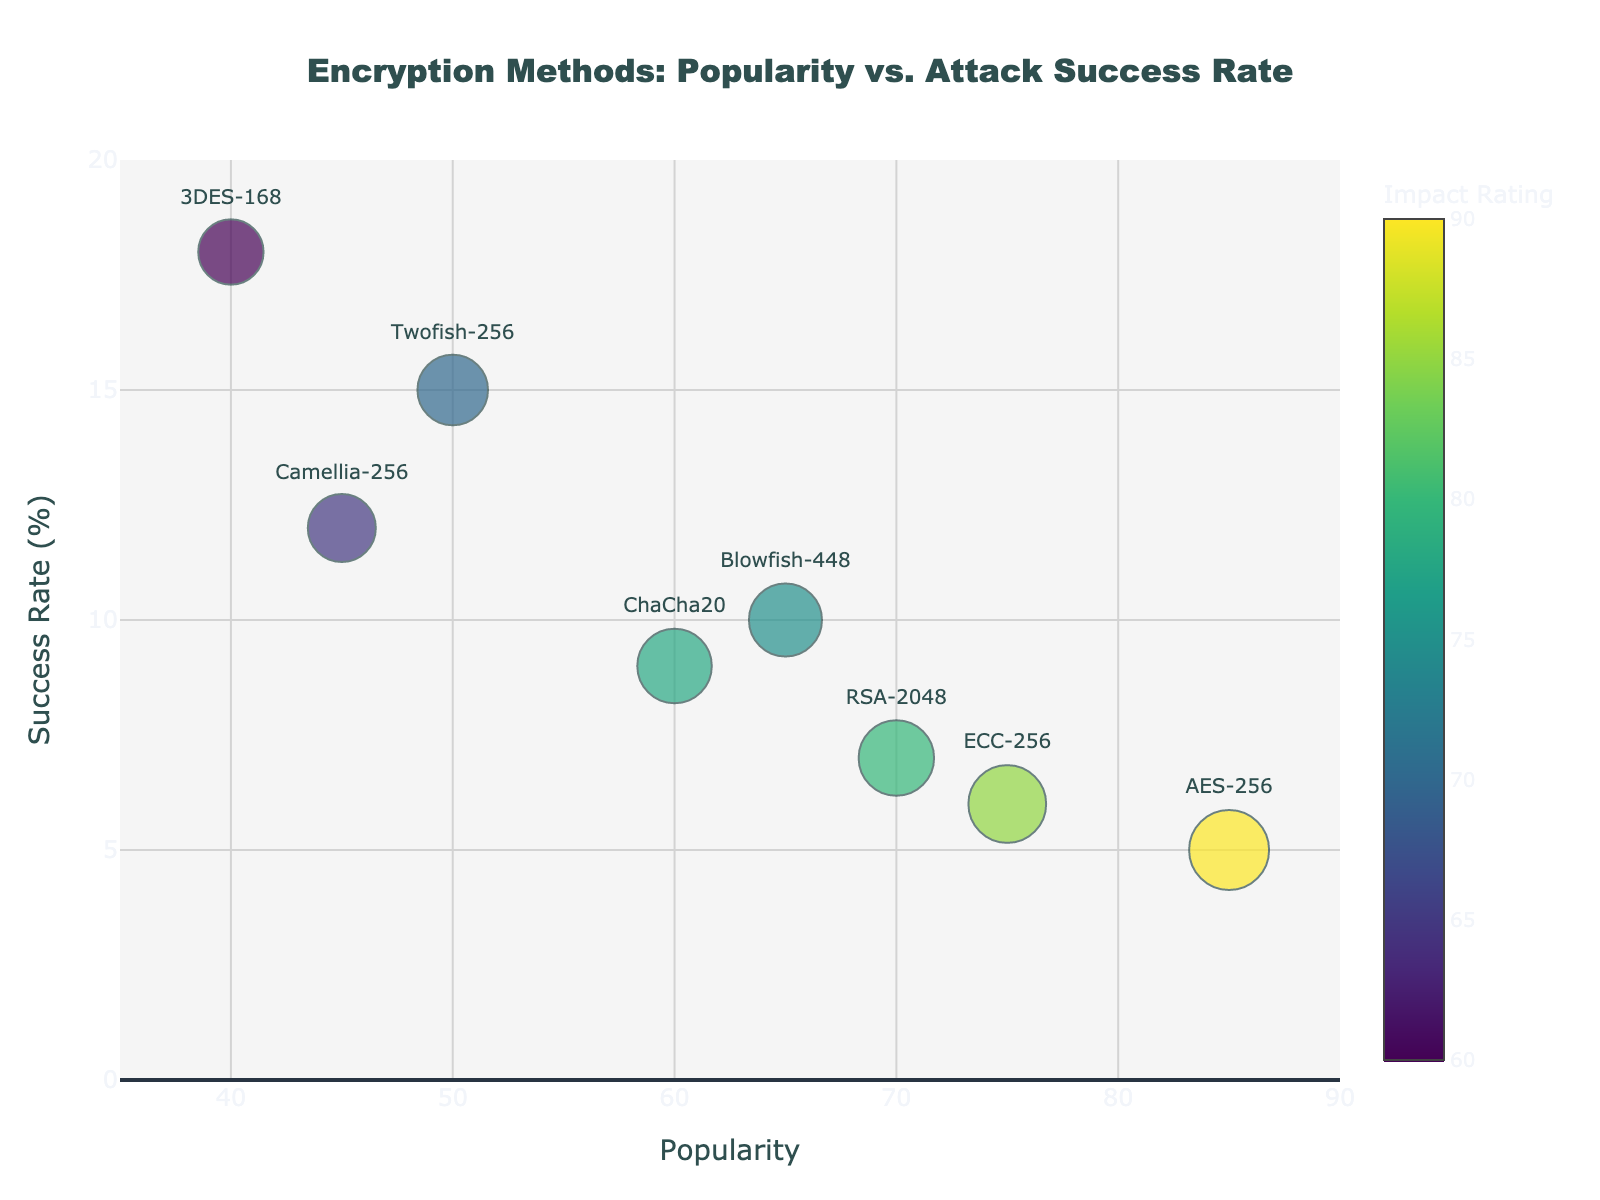How many encryption methods are depicted in the figure? Count the individual data points in the figure. Each data point corresponds to a unique encryption method.
Answer: 8 What is the title of the figure? Read the text prominently displayed at the top-center of the figure.
Answer: Encryption Methods: Popularity vs. Attack Success Rate Which encryption method has the highest popularity? Identify the encryption method located furthest to the right along the x-axis (Popularity).
Answer: AES-256 Which encryption method has the lowest success rate? Identify the encryption method positioned lowest along the y-axis (Success Rate).
Answer: AES-256 What range of values is depicted on the x-axis? Look at the minimum and maximum values marked on the x-axis (Popularity).
Answer: 35 to 90 What is the color range used to indicate the impact rating? Observe the color scale bar located to the right of the figure, which shows the range of colors corresponding to different Impact Ratings.
Answer: Viridis colorscale Which encryption method has the largest bubble, indicating the highest impact rating? Find the largest bubble in the figure, as bubble size represents the Impact Rating.
Answer: AES-256 Is there any encryption method with both high popularity and high success rate of attacks? Look for a data point that is positioned both high on the y-axis and far to the right on the x-axis.
Answer: No What is the impact rating for ChaCha20? Hover over the bubble for ChaCha20 or refer to the color and size of the bubble, which is 78.
Answer: 78 How does the success rate of 3DES-168 compare with that of RSA-2048? Check the y-axis positions of the points representing 3DES-168 and RSA-2048, and compare their Success Rates.
Answer: 3DES-168 has a higher success rate than RSA-2048 